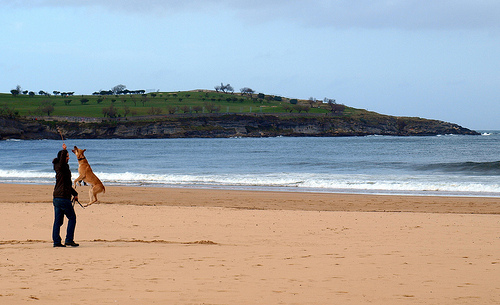How many dogs are visible? I apologize for the confusion, but it appears that there are no dogs visible in the image. Instead, we can see a person standing on the beach with a kite. 